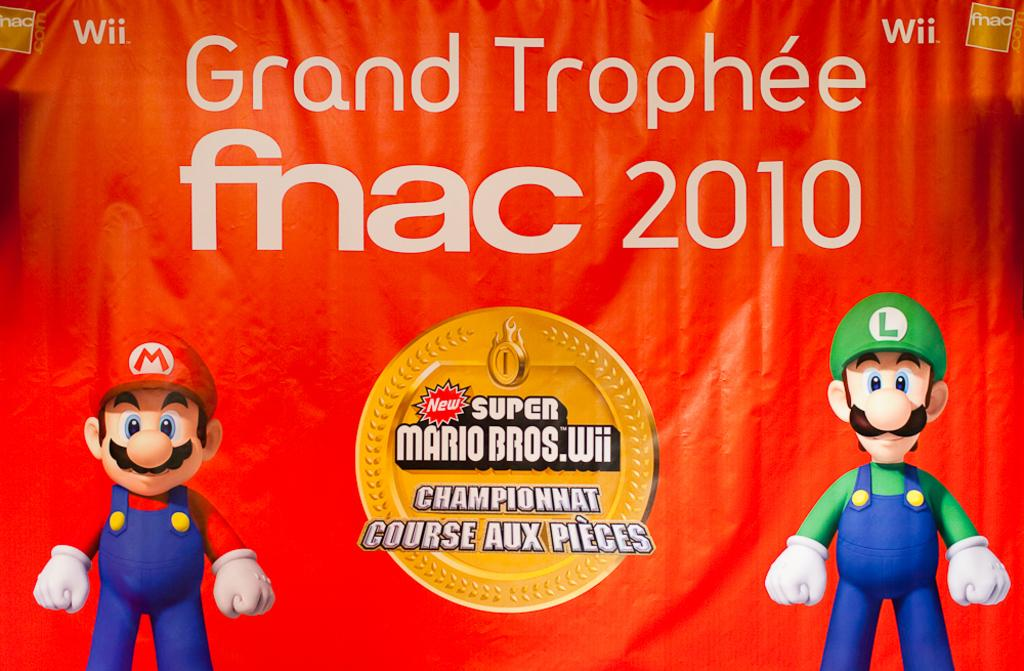What type of image is being described? The image is a banner. What can be found in the center of the banner? There is text and a logo in the center of the image. What is present on both sides of the banner? Cartoons are on both the left and right sides of the image. How many nails are used to hang the banner in the image? There is no information about nails or hanging the banner in the image. --- Facts: 1. There is a person sitting on a chair in the image. 2. The person is holding a book. 3. The book has a blue cover. 4. The chair is made of wood. 5. There is a lamp on a table next to the chair. Absurd Topics: fish, bicycle, ocean Conversation: What is the person in the image doing? The person is sitting on a chair in the image. What is the person holding in the image? The person is holding a book in the image. What color is the book's cover? The book has a blue cover. What is the chair made of? The chair is made of wood. What is present on the table next to the chair? There is a lamp on a table next to the chair. Reasoning: Let's think step by step in order to produce the conversation. We start by identifying the main subject in the image, which is the person sitting on a chair. Then, we expand the conversation to include other items that are also visible, such as the book, the book's cover, the chair's material, and the lamp on the table. Each question is designed to elicit a specific detail about the image that is known from the provided facts. Absurd Question/Answer: How many fish can be seen swimming in the ocean in the image? There is no ocean or fish present in the image. 